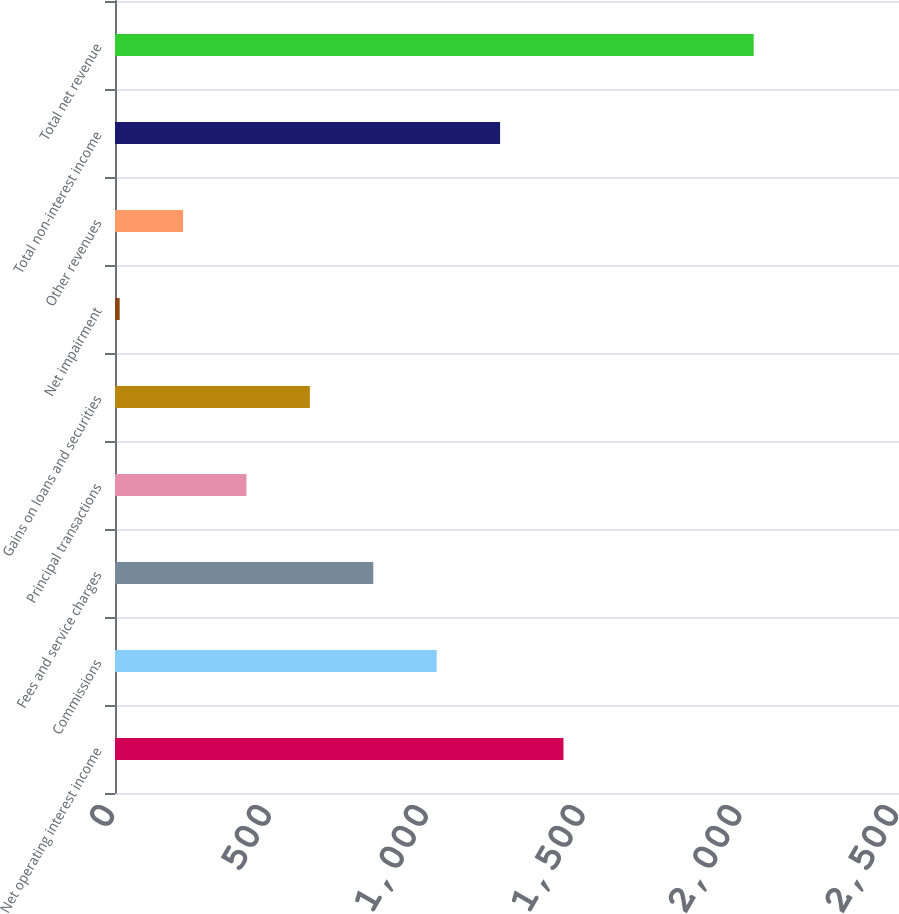<chart> <loc_0><loc_0><loc_500><loc_500><bar_chart><fcel>Net operating interest income<fcel>Commissions<fcel>Fees and service charges<fcel>Principal transactions<fcel>Gains on loans and securities<fcel>Net impairment<fcel>Other revenues<fcel>Total non-interest income<fcel>Total net revenue<nl><fcel>1430.09<fcel>1025.75<fcel>823.58<fcel>419.24<fcel>621.41<fcel>14.9<fcel>217.07<fcel>1227.92<fcel>2036.6<nl></chart> 